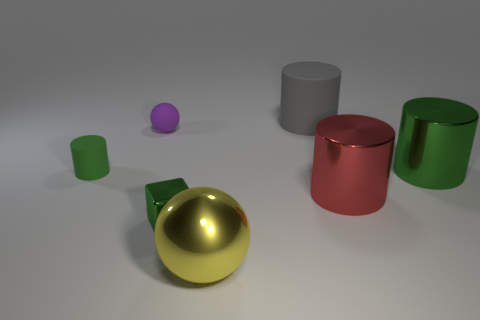Add 2 gray rubber cylinders. How many objects exist? 9 Subtract all cubes. How many objects are left? 6 Add 3 cyan matte things. How many cyan matte things exist? 3 Subtract 0 cyan cylinders. How many objects are left? 7 Subtract all gray rubber cylinders. Subtract all tiny green metallic objects. How many objects are left? 5 Add 3 red metallic objects. How many red metallic objects are left? 4 